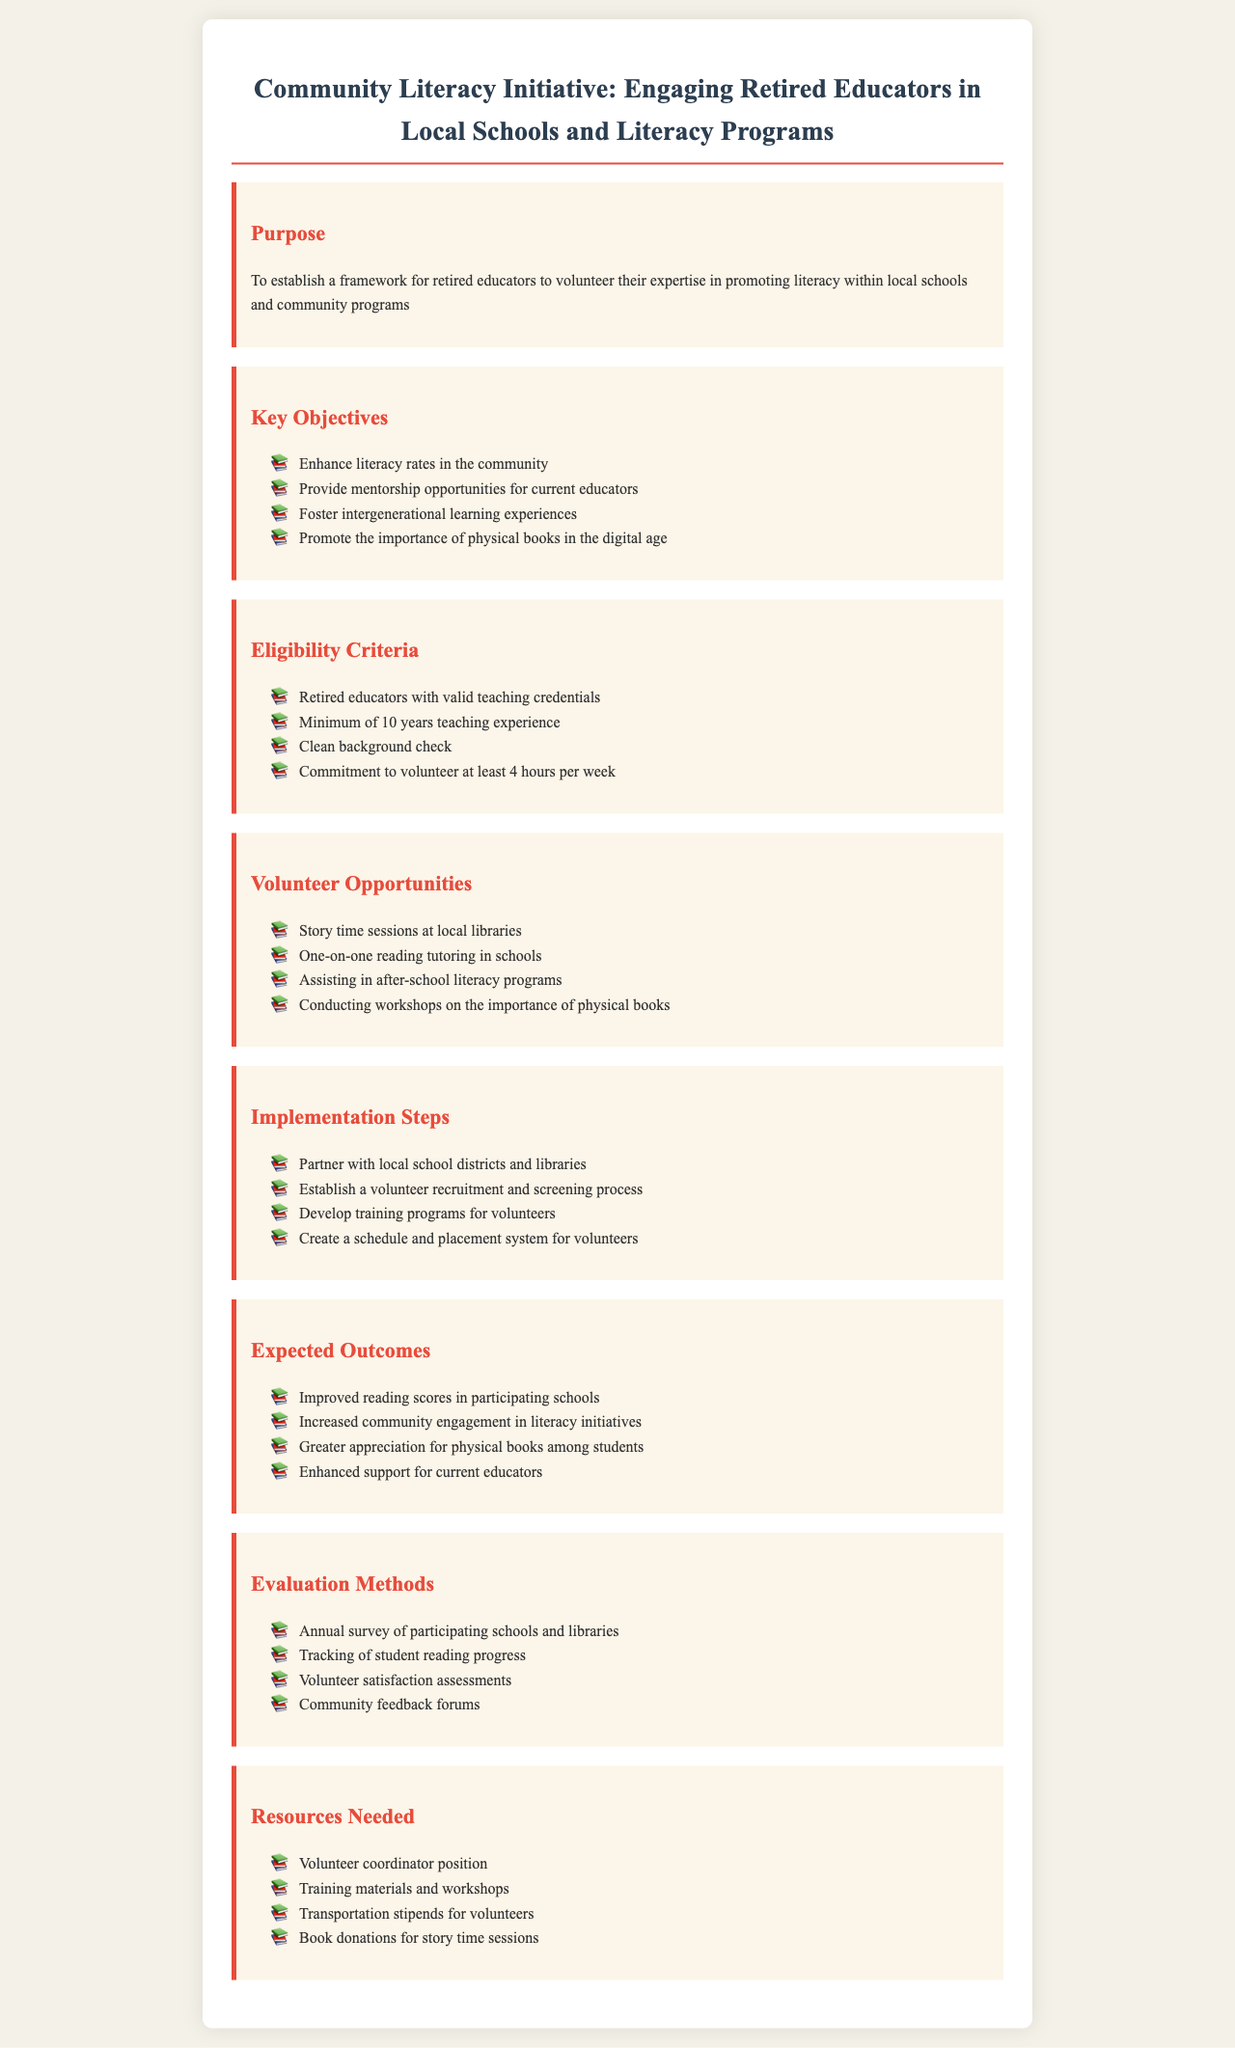What is the main purpose of the initiative? The main purpose is to establish a framework for retired educators to volunteer their expertise in promoting literacy within local schools and community programs.
Answer: To establish a framework for retired educators to volunteer their expertise in promoting literacy within local schools and community programs How many years of teaching experience is required? The document states a minimum of 10 years teaching experience is required for eligibility.
Answer: Minimum of 10 years teaching experience What is one of the key objectives of the initiative? One of the key objectives mentioned is to promote the importance of physical books in the digital age.
Answer: Promote the importance of physical books in the digital age What is the expected outcome related to community engagement? The expected outcome states that there will be increased community engagement in literacy initiatives.
Answer: Increased community engagement in literacy initiatives How often do volunteers need to commit to volunteer hours? The document specifies that volunteers must commit to at least 4 hours per week.
Answer: At least 4 hours per week 